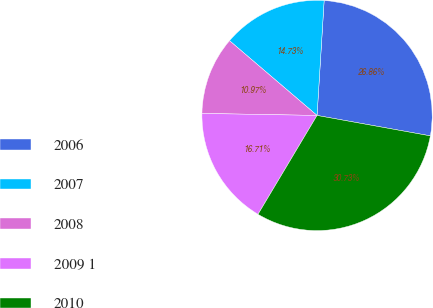<chart> <loc_0><loc_0><loc_500><loc_500><pie_chart><fcel>2006<fcel>2007<fcel>2008<fcel>2009 1<fcel>2010<nl><fcel>26.86%<fcel>14.73%<fcel>10.97%<fcel>16.71%<fcel>30.73%<nl></chart> 